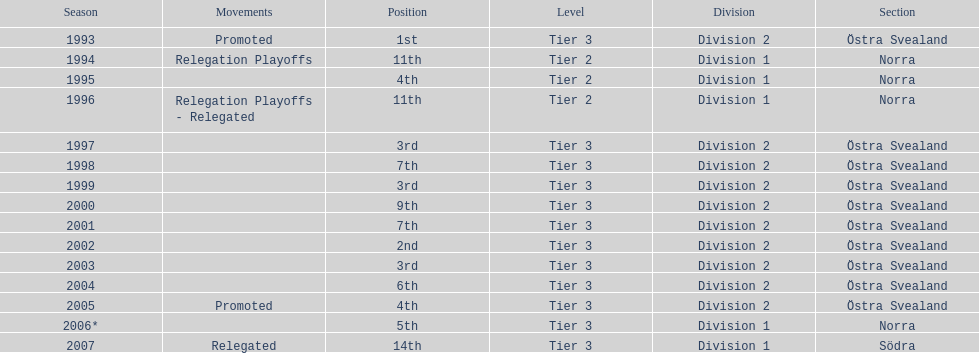How many times did they finish above 5th place in division 2 tier 3? 6. 